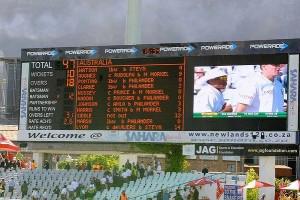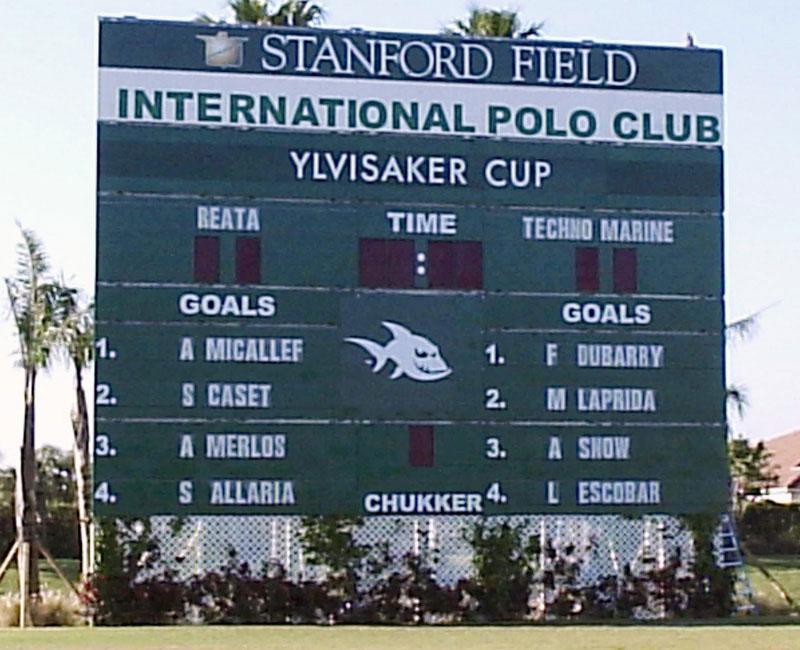The first image is the image on the left, the second image is the image on the right. Examine the images to the left and right. Is the description "The sport being played in the left image was invented in the United States." accurate? Answer yes or no. No. The first image is the image on the left, the second image is the image on the right. For the images displayed, is the sentence "The left image features a rectangular sign containing a screen that displays a sporting event." factually correct? Answer yes or no. Yes. 